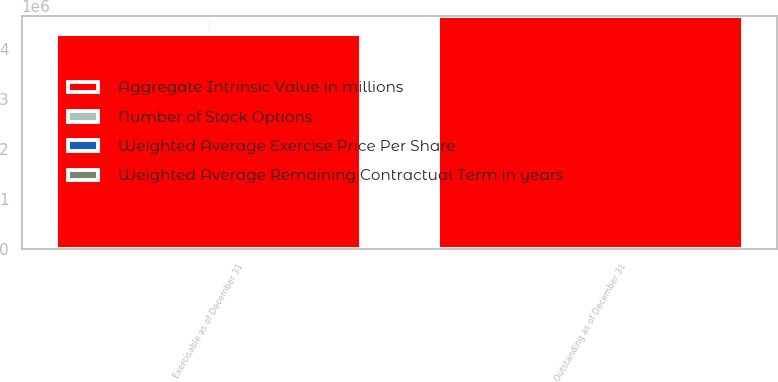<chart> <loc_0><loc_0><loc_500><loc_500><stacked_bar_chart><ecel><fcel>Outstanding as of December 31<fcel>Exercisable as of December 31<nl><fcel>Aggregate Intrinsic Value in millions<fcel>4.66922e+06<fcel>4.31541e+06<nl><fcel>Weighted Average Remaining Contractual Term in years<fcel>21.48<fcel>19.99<nl><fcel>Number of Stock Options<fcel>4.5<fcel>4.2<nl><fcel>Weighted Average Exercise Price Per Share<fcel>131<fcel>127<nl></chart> 